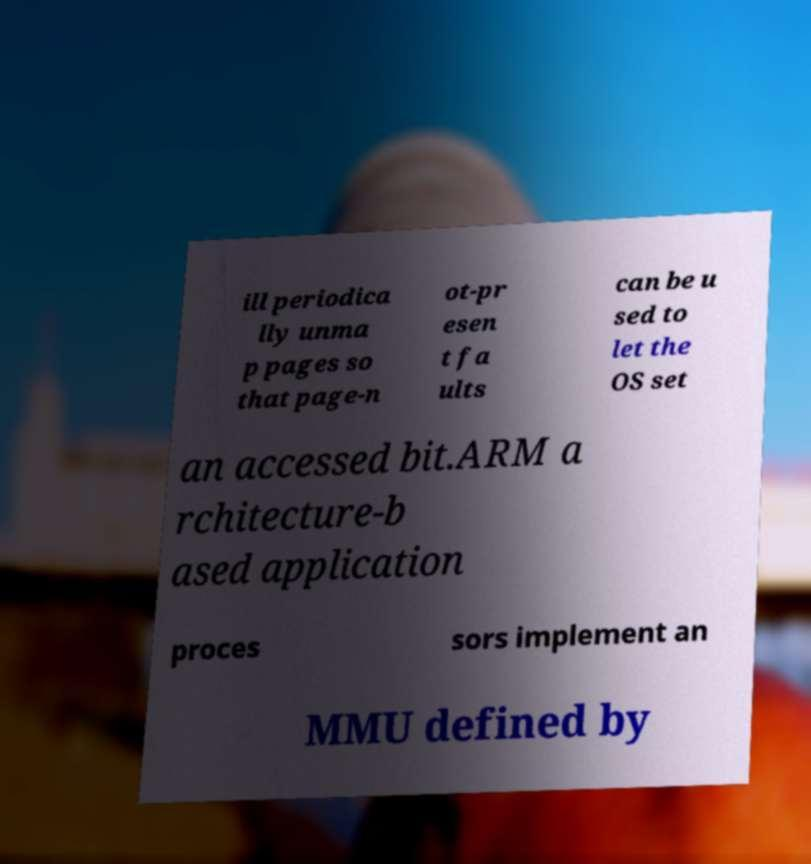I need the written content from this picture converted into text. Can you do that? ill periodica lly unma p pages so that page-n ot-pr esen t fa ults can be u sed to let the OS set an accessed bit.ARM a rchitecture-b ased application proces sors implement an MMU defined by 